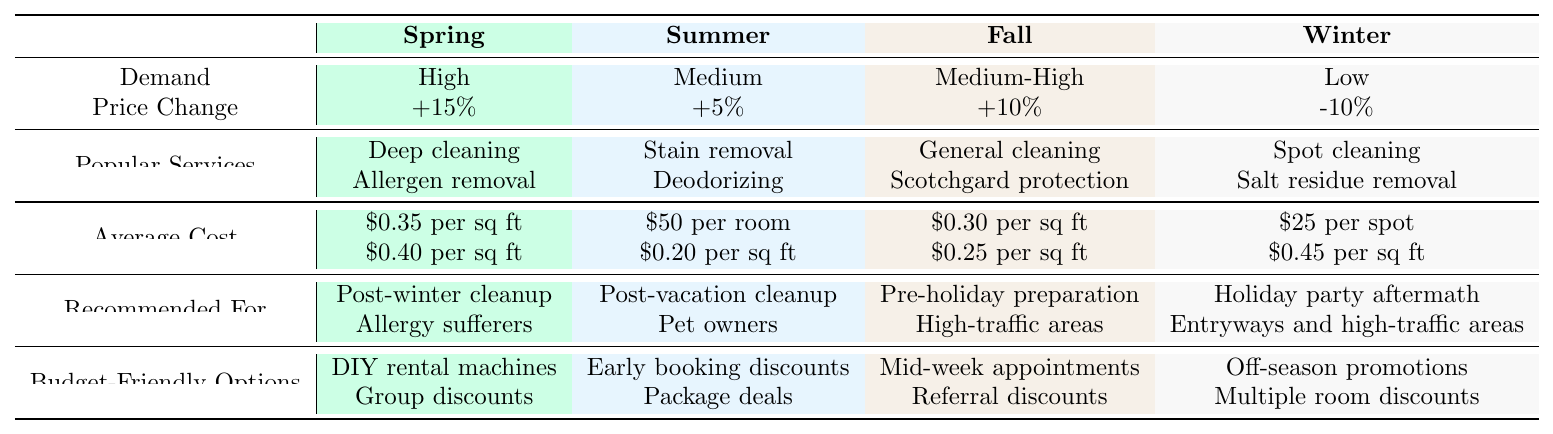What season has the highest demand for carpet cleaning services? From the table, Spring is noted as having "High" demand, which is indicated in the first row under the Spring column.
Answer: Spring Which carpet cleaning service is the most recommended for allergy sufferers? The service "Allergen removal" is listed under the Spring season, specifically recommended for allergy sufferers.
Answer: Allergen removal How much does it cost on average for deodorizing in the summer season? According to the table, the average cost for deodorizing during the summer is "$0.20 per sq ft."
Answer: $0.20 per sq ft What is the price change for carpet cleaning services in the winter? The table indicates a price change of "-10%" for winter, as seen in the price change row under the Winter column.
Answer: -10% Which season offers budget-friendly options for weekend appointments? The table lists "Mid-week appointments" as a budget-friendly option in Fall, but it does not mention weekend options. This implies that there are no specific budget-friendly options for weekend appointments.
Answer: No If a homeowner wants to prepare for the holidays with carpet cleaning, which season should they choose? The Fall season is recommended for pre-holiday preparation, as indicated in the "Recommended For" section of the Fall column.
Answer: Fall What is the combined average cost for spot cleaning and salt residue removal in the winter? To find the combined average cost, add $25 (for spot cleaning) and $0.45 per sq ft (for salt residue removal). The total is $25 + $0.45 = $25.45.
Answer: $25.45 How do the average costs for services in Spring compare to those in Winter? In Spring, the average costs range from $0.35 to $0.40 per sq ft, while in Winter, they include $25 per spot and $0.45 per sq ft. Spring services average higher for sq ft services, but spot cleaning in Winter has a fixed cost. Comparing gives a general higher cost for Spring's sq ft services.
Answer: Spring services are generally more expensive than Winter's What is the price percentage increase from Summer to Fall? The price changes from Summer (+5%) to Fall (+10%) signify a difference of +10% - (+5%) = +5%. This reflects a 5% increase from Summer to Fall.
Answer: +5% Which service is budget-friendly for homeowners looking to clean before the holidays? Mid-week appointments are listed as a budget-friendly option for the Fall season, which is recommended for pre-holiday preparations.
Answer: Mid-week appointments 